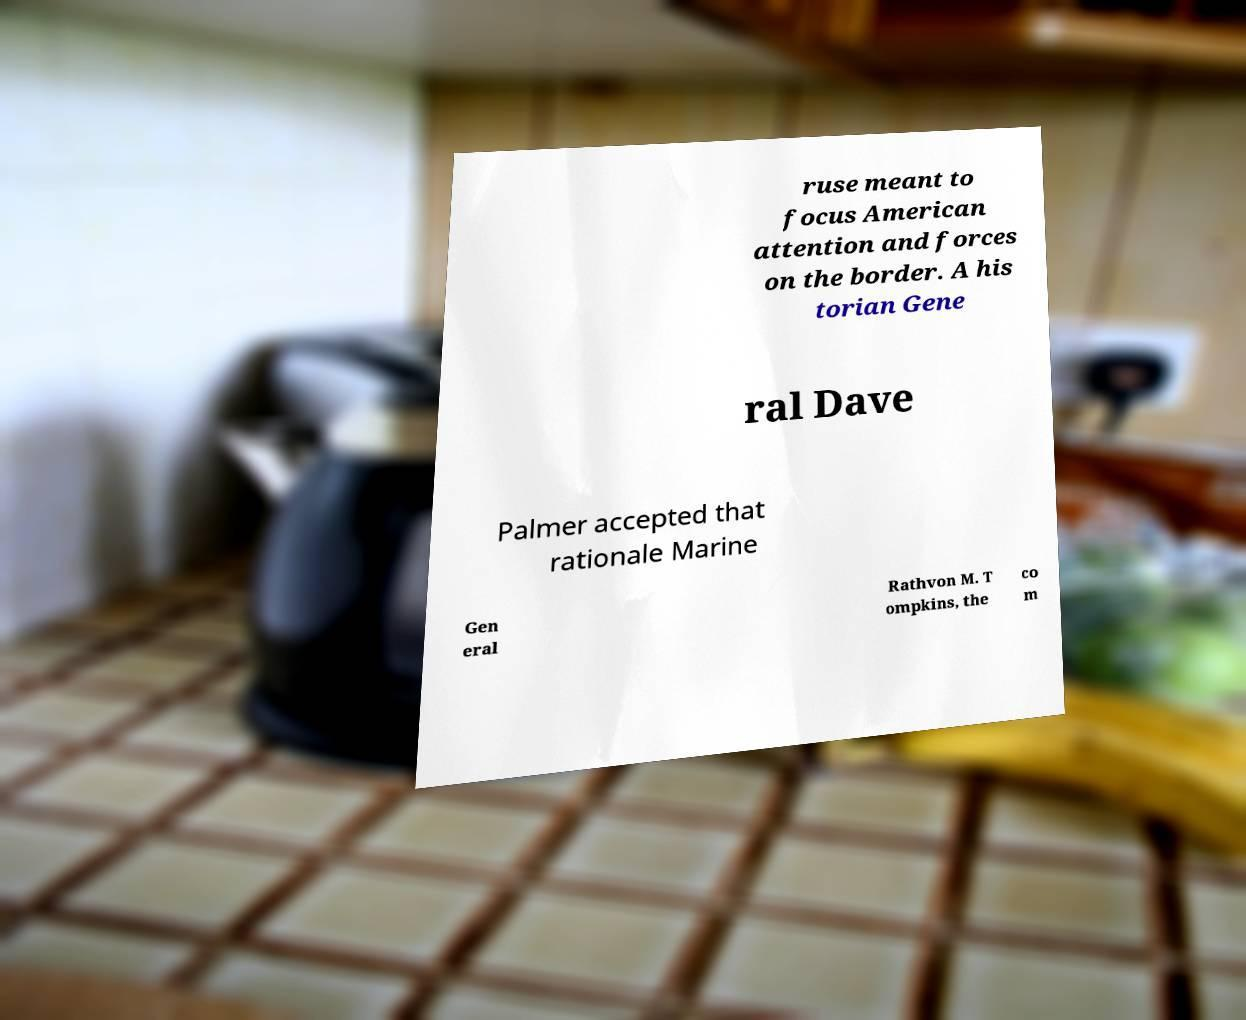Could you assist in decoding the text presented in this image and type it out clearly? ruse meant to focus American attention and forces on the border. A his torian Gene ral Dave Palmer accepted that rationale Marine Gen eral Rathvon M. T ompkins, the co m 